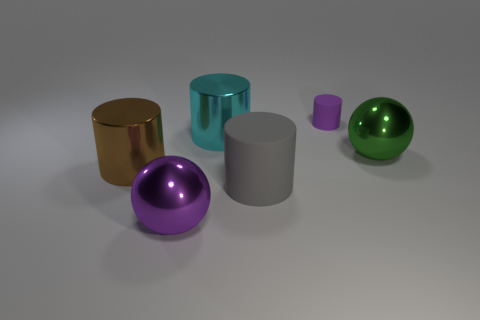What is the color of the ball that is the same material as the large purple thing?
Make the answer very short. Green. Is the material of the small purple cylinder the same as the large object right of the tiny purple matte cylinder?
Ensure brevity in your answer.  No. How many gray cylinders are the same material as the big cyan cylinder?
Ensure brevity in your answer.  0. There is a metallic thing that is left of the purple metal object; what is its shape?
Keep it short and to the point. Cylinder. Are the big sphere that is to the left of the purple rubber object and the big ball behind the big brown object made of the same material?
Give a very brief answer. Yes. Are there any other large purple things of the same shape as the purple shiny object?
Give a very brief answer. No. How many things are big metal spheres on the left side of the large cyan metallic object or metallic objects?
Provide a short and direct response. 4. Is the number of big things behind the tiny thing greater than the number of large cyan metallic things behind the large brown metallic cylinder?
Provide a succinct answer. No. What number of matte things are either large cyan objects or tiny green cubes?
Keep it short and to the point. 0. What material is the big ball that is the same color as the tiny cylinder?
Offer a very short reply. Metal. 